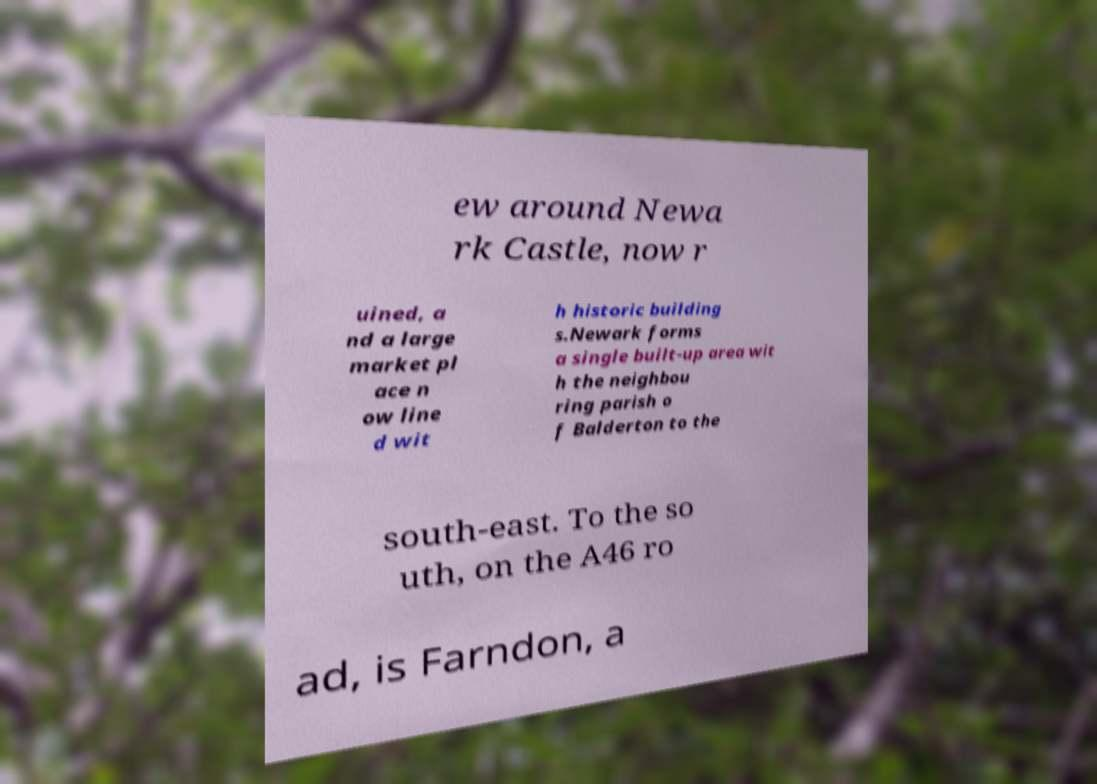I need the written content from this picture converted into text. Can you do that? ew around Newa rk Castle, now r uined, a nd a large market pl ace n ow line d wit h historic building s.Newark forms a single built-up area wit h the neighbou ring parish o f Balderton to the south-east. To the so uth, on the A46 ro ad, is Farndon, a 